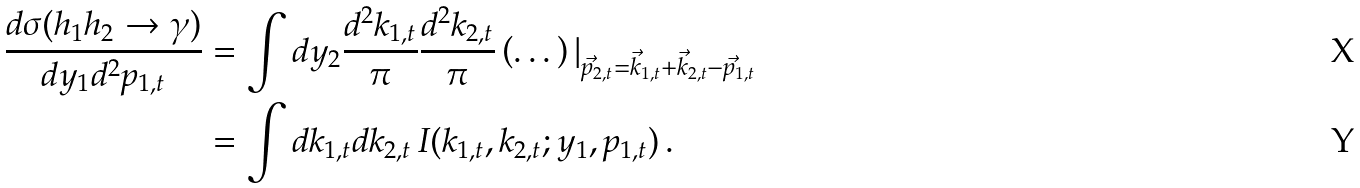<formula> <loc_0><loc_0><loc_500><loc_500>\frac { d \sigma ( h _ { 1 } h _ { 2 } \to \gamma ) } { d y _ { 1 } d ^ { 2 } p _ { 1 , t } } & = \int d y _ { 2 } \frac { d ^ { 2 } k _ { 1 , t } } { \pi } \frac { d ^ { 2 } k _ { 2 , t } } { \pi } \left ( \dots \right ) | _ { \vec { p } _ { 2 , t } = \vec { k } _ { 1 , t } + \vec { k } _ { 2 , t } - \vec { p } _ { 1 , t } } \\ & = \int d k _ { 1 , t } d k _ { 2 , t } \, I ( k _ { 1 , t } , k _ { 2 , t } ; y _ { 1 } , p _ { 1 , t } ) \, .</formula> 